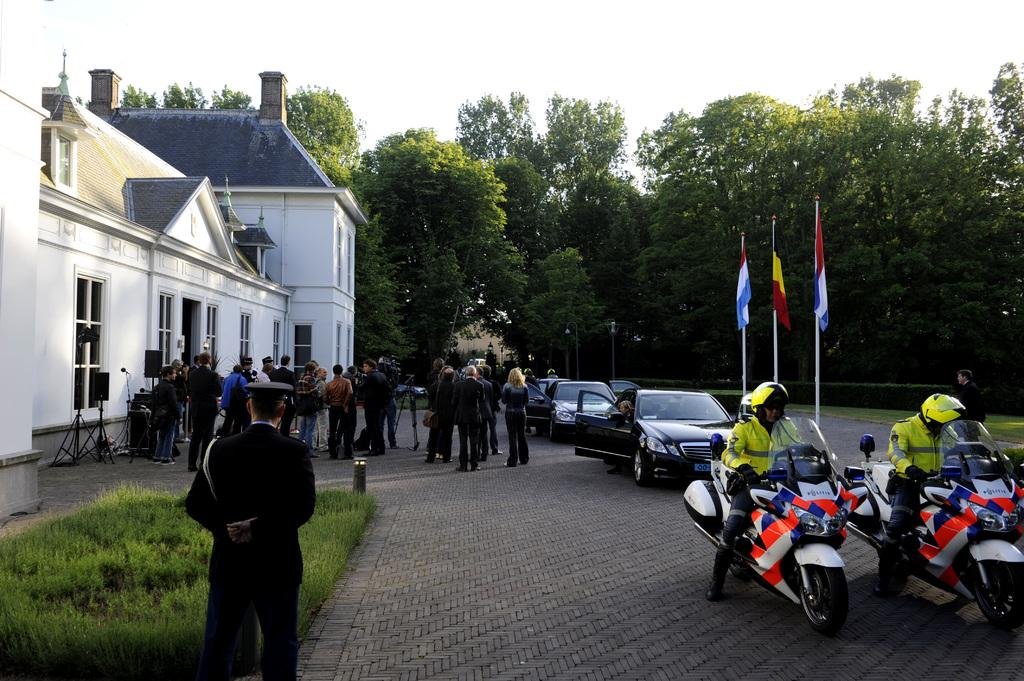What type of vehicles can be seen on the road in the image? There are two motorcycles and three cars on the road in the image. What else can be seen in the image besides vehicles? There is a group of people standing, a house, trees, and flags in the image. What type of toothbrush is being used by the person standing next to the house? There is no toothbrush or person brushing their teeth visible in the image. 